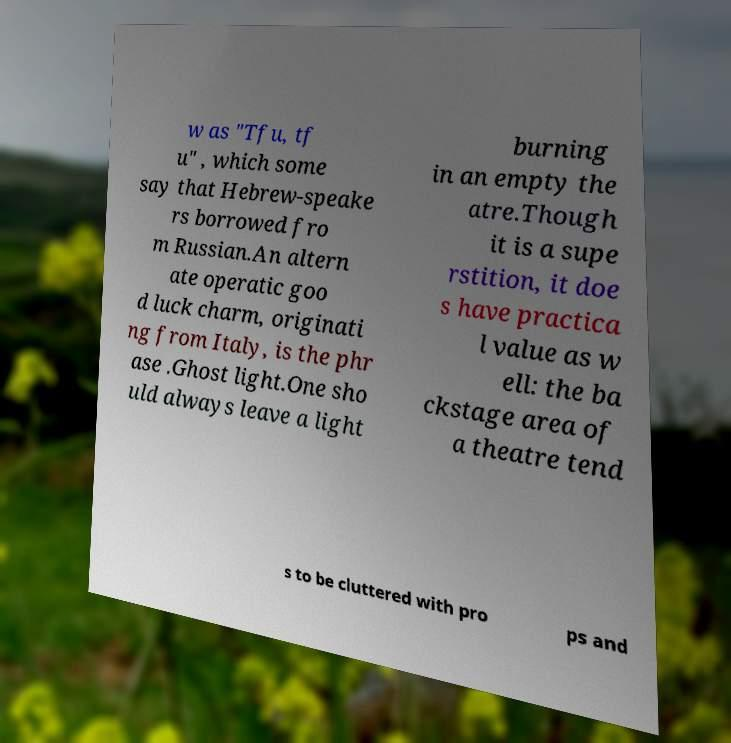Can you read and provide the text displayed in the image?This photo seems to have some interesting text. Can you extract and type it out for me? w as "Tfu, tf u" , which some say that Hebrew-speake rs borrowed fro m Russian.An altern ate operatic goo d luck charm, originati ng from Italy, is the phr ase .Ghost light.One sho uld always leave a light burning in an empty the atre.Though it is a supe rstition, it doe s have practica l value as w ell: the ba ckstage area of a theatre tend s to be cluttered with pro ps and 